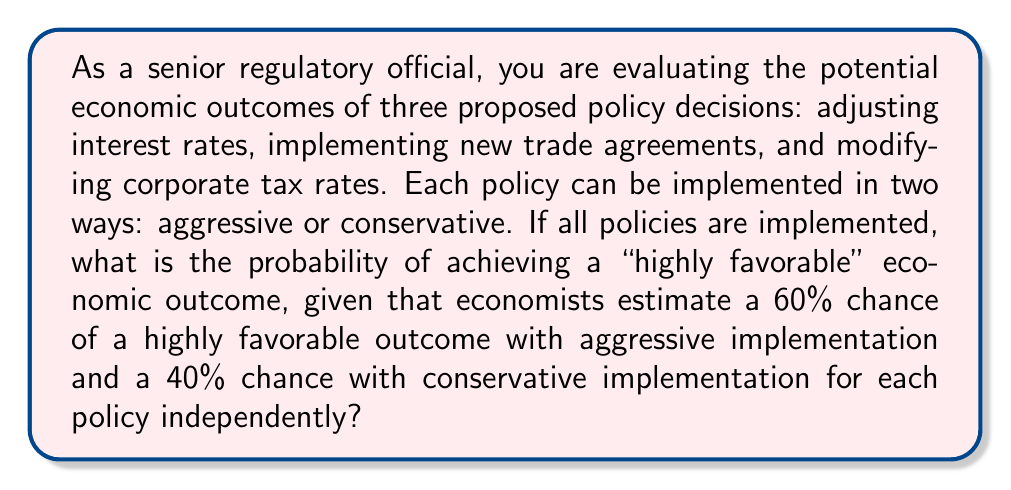Teach me how to tackle this problem. Let's approach this step-by-step:

1) We have three independent policy decisions, each with two possible implementations (aggressive or conservative).

2) For a "highly favorable" outcome, we need to calculate the probability of success for each possible combination of policy implementations.

3) The total number of possible combinations is $2^3 = 8$, as each of the three policies has two options.

4) Let's define the probability of success for each implementation:
   $P(\text{aggressive}) = 0.60$
   $P(\text{conservative}) = 0.40$

5) We need to calculate the probability of success for each combination:

   a) All aggressive: $0.60 \times 0.60 \times 0.60 = 0.216$
   b) Two aggressive, one conservative: $0.60 \times 0.60 \times 0.40 = 0.144$ (3 ways)
   c) One aggressive, two conservative: $0.60 \times 0.40 \times 0.40 = 0.096$ (3 ways)
   d) All conservative: $0.40 \times 0.40 \times 0.40 = 0.064$

6) To get the total probability, we sum all these probabilities:

   $$P(\text{highly favorable}) = 0.216 + (3 \times 0.144) + (3 \times 0.096) + 0.064$$

7) Calculating:
   $$P(\text{highly favorable}) = 0.216 + 0.432 + 0.288 + 0.064 = 1.000$$

Therefore, the probability of achieving a "highly favorable" economic outcome is 1 or 100%.
Answer: The probability of achieving a "highly favorable" economic outcome is 1 (or 100%). 